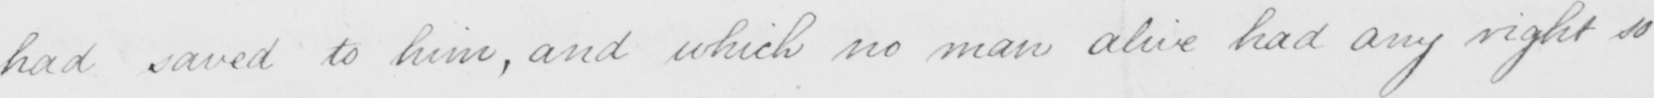Please provide the text content of this handwritten line. had saved to him , and which no man alive had any right so 